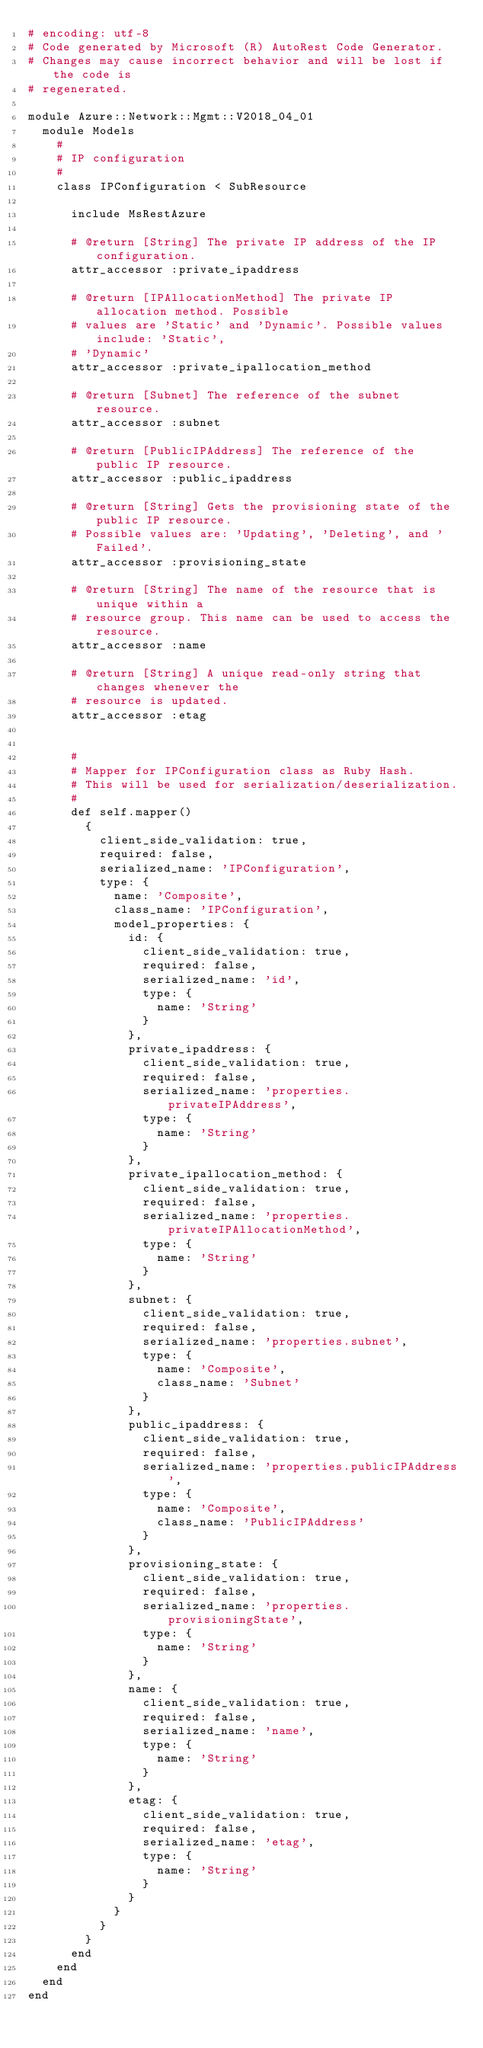Convert code to text. <code><loc_0><loc_0><loc_500><loc_500><_Ruby_># encoding: utf-8
# Code generated by Microsoft (R) AutoRest Code Generator.
# Changes may cause incorrect behavior and will be lost if the code is
# regenerated.

module Azure::Network::Mgmt::V2018_04_01
  module Models
    #
    # IP configuration
    #
    class IPConfiguration < SubResource

      include MsRestAzure

      # @return [String] The private IP address of the IP configuration.
      attr_accessor :private_ipaddress

      # @return [IPAllocationMethod] The private IP allocation method. Possible
      # values are 'Static' and 'Dynamic'. Possible values include: 'Static',
      # 'Dynamic'
      attr_accessor :private_ipallocation_method

      # @return [Subnet] The reference of the subnet resource.
      attr_accessor :subnet

      # @return [PublicIPAddress] The reference of the public IP resource.
      attr_accessor :public_ipaddress

      # @return [String] Gets the provisioning state of the public IP resource.
      # Possible values are: 'Updating', 'Deleting', and 'Failed'.
      attr_accessor :provisioning_state

      # @return [String] The name of the resource that is unique within a
      # resource group. This name can be used to access the resource.
      attr_accessor :name

      # @return [String] A unique read-only string that changes whenever the
      # resource is updated.
      attr_accessor :etag


      #
      # Mapper for IPConfiguration class as Ruby Hash.
      # This will be used for serialization/deserialization.
      #
      def self.mapper()
        {
          client_side_validation: true,
          required: false,
          serialized_name: 'IPConfiguration',
          type: {
            name: 'Composite',
            class_name: 'IPConfiguration',
            model_properties: {
              id: {
                client_side_validation: true,
                required: false,
                serialized_name: 'id',
                type: {
                  name: 'String'
                }
              },
              private_ipaddress: {
                client_side_validation: true,
                required: false,
                serialized_name: 'properties.privateIPAddress',
                type: {
                  name: 'String'
                }
              },
              private_ipallocation_method: {
                client_side_validation: true,
                required: false,
                serialized_name: 'properties.privateIPAllocationMethod',
                type: {
                  name: 'String'
                }
              },
              subnet: {
                client_side_validation: true,
                required: false,
                serialized_name: 'properties.subnet',
                type: {
                  name: 'Composite',
                  class_name: 'Subnet'
                }
              },
              public_ipaddress: {
                client_side_validation: true,
                required: false,
                serialized_name: 'properties.publicIPAddress',
                type: {
                  name: 'Composite',
                  class_name: 'PublicIPAddress'
                }
              },
              provisioning_state: {
                client_side_validation: true,
                required: false,
                serialized_name: 'properties.provisioningState',
                type: {
                  name: 'String'
                }
              },
              name: {
                client_side_validation: true,
                required: false,
                serialized_name: 'name',
                type: {
                  name: 'String'
                }
              },
              etag: {
                client_side_validation: true,
                required: false,
                serialized_name: 'etag',
                type: {
                  name: 'String'
                }
              }
            }
          }
        }
      end
    end
  end
end
</code> 